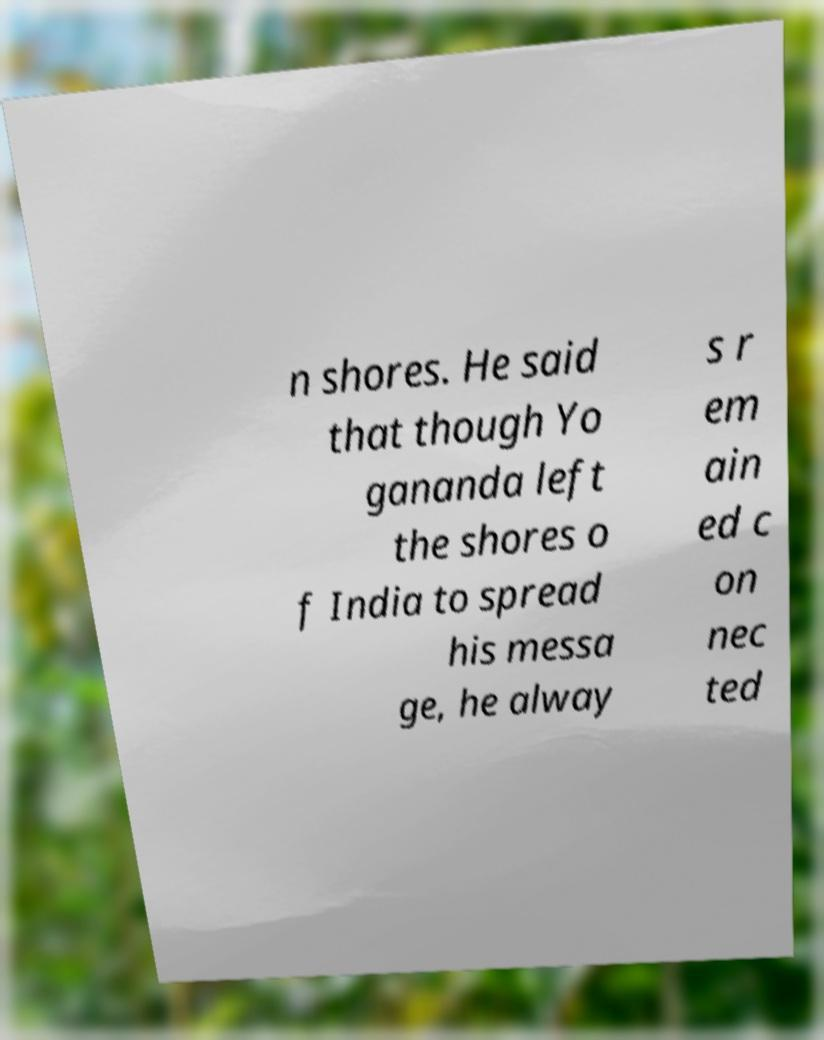I need the written content from this picture converted into text. Can you do that? n shores. He said that though Yo gananda left the shores o f India to spread his messa ge, he alway s r em ain ed c on nec ted 